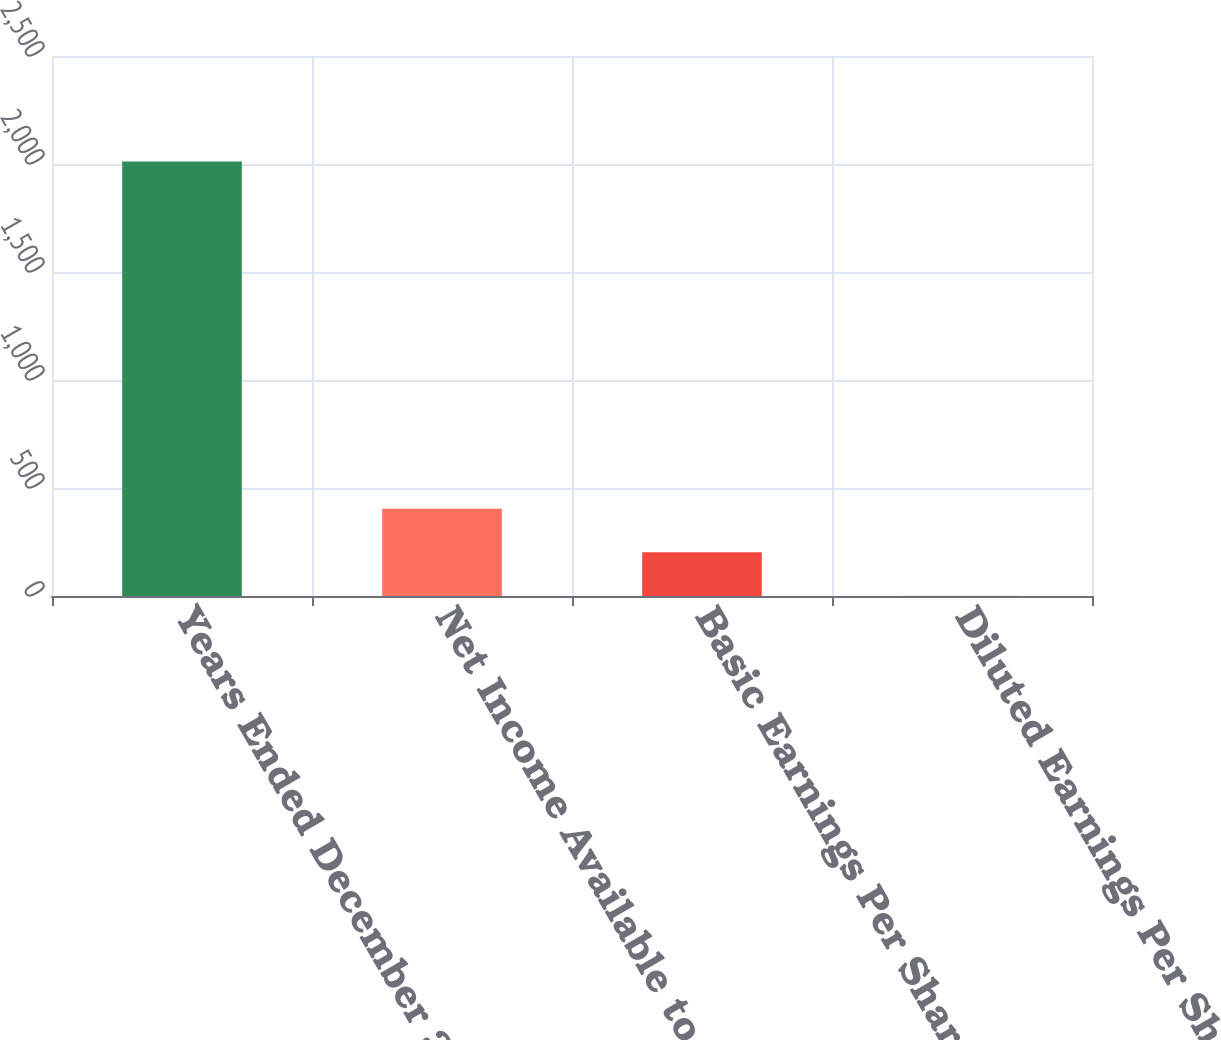Convert chart. <chart><loc_0><loc_0><loc_500><loc_500><bar_chart><fcel>Years Ended December 31<fcel>Net Income Available to Common<fcel>Basic Earnings Per Share<fcel>Diluted Earnings Per Share<nl><fcel>2012<fcel>403.54<fcel>202.48<fcel>1.42<nl></chart> 